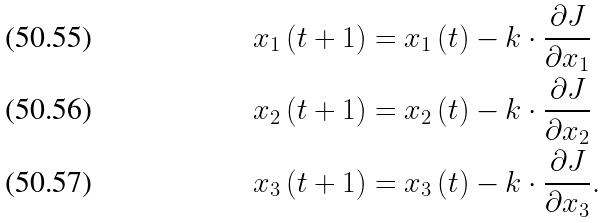Convert formula to latex. <formula><loc_0><loc_0><loc_500><loc_500>x _ { 1 } \left ( t + 1 \right ) & = x _ { 1 } \left ( t \right ) - k \cdot \frac { \partial J } { \partial x _ { 1 } } \\ x _ { 2 } \left ( t + 1 \right ) & = x _ { 2 } \left ( t \right ) - k \cdot \frac { \partial J } { \partial x _ { 2 } } \\ x _ { 3 } \left ( t + 1 \right ) & = x _ { 3 } \left ( t \right ) - k \cdot \frac { \partial J } { \partial x _ { 3 } } .</formula> 